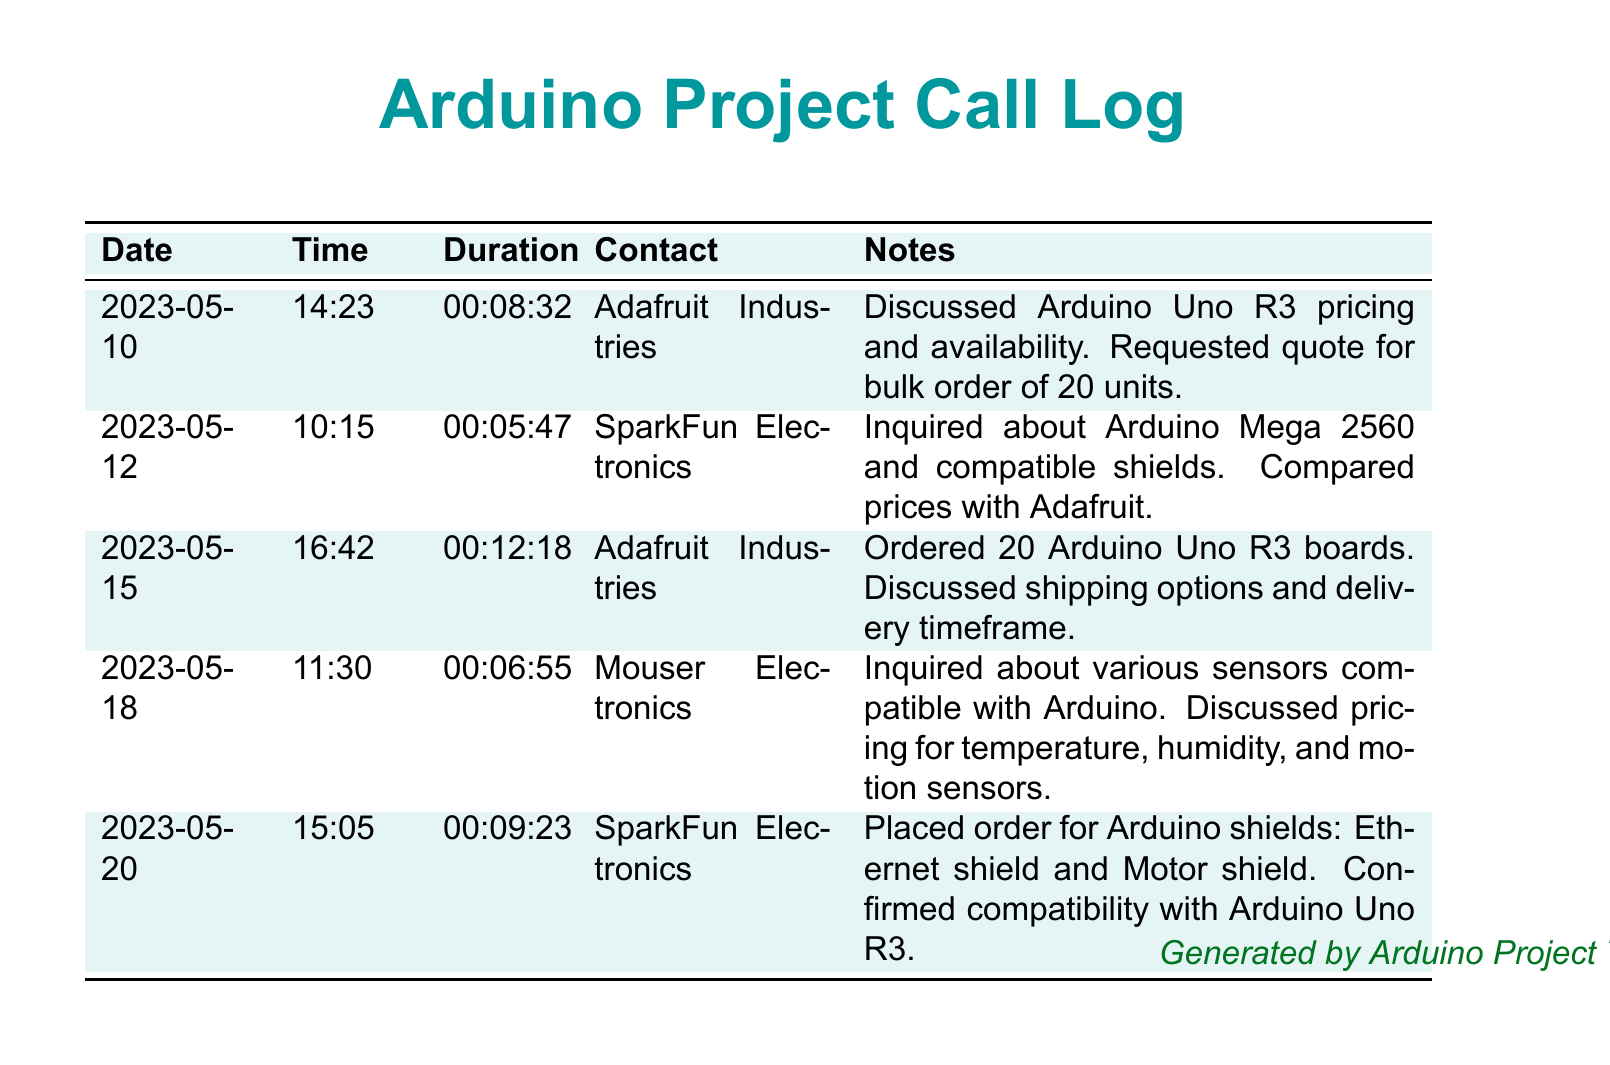What is the date of the first call? The first call detail lists a date of May 10, 2023.
Answer: 2023-05-10 Who was contacted in the last conversation? The last entry in the call log shows that SparkFun Electronics was contacted.
Answer: SparkFun Electronics What was the duration of the call on May 12, 2023? The call duration for May 12, 2023, is documented as 5 minutes and 47 seconds.
Answer: 00:05:47 How many Arduino Uno R3 boards were ordered? The call on May 15, 2023, confirms an order for 20 Arduino Uno R3 boards.
Answer: 20 Which supplier was compared for prices with Adafruit? The log indicates SparkFun Electronics was compared for pricing.
Answer: SparkFun Electronics What specific shields were ordered on May 20, 2023? The note for May 20 indicates that an Ethernet shield and Motor shield were ordered.
Answer: Ethernet shield and Motor shield How many suppliers were involved in the call log? The document mentions a total of three different suppliers contacted during the calls.
Answer: Three What components were inquired about on May 18, 2023? The call log shows that various sensors compatible with Arduino were inquired about, specifically temperature, humidity, and motion sensors.
Answer: Sensors 